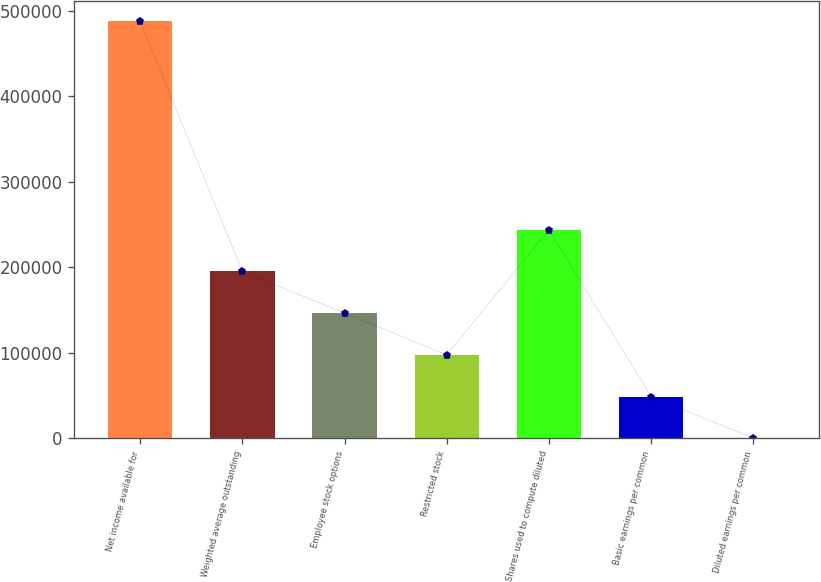Convert chart to OTSL. <chart><loc_0><loc_0><loc_500><loc_500><bar_chart><fcel>Net income available for<fcel>Weighted average outstanding<fcel>Employee stock options<fcel>Restricted stock<fcel>Shares used to compute diluted<fcel>Basic earnings per common<fcel>Diluted earnings per common<nl><fcel>487423<fcel>194971<fcel>146229<fcel>97486.9<fcel>243713<fcel>48744.9<fcel>2.9<nl></chart> 